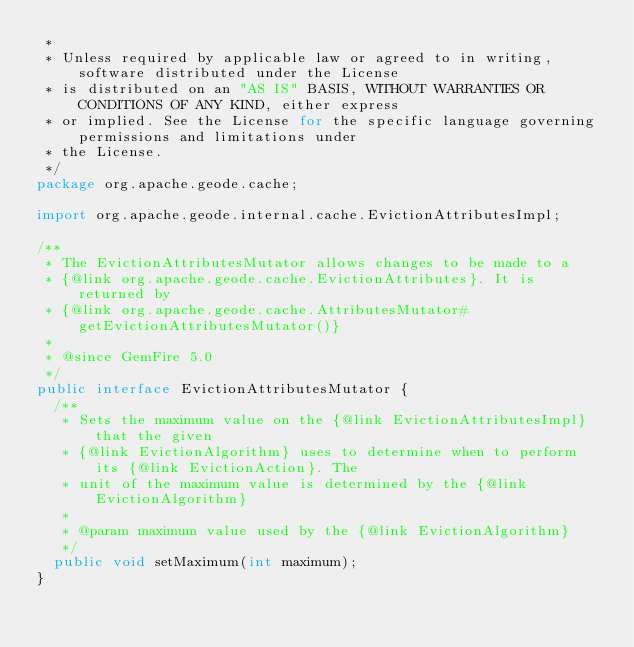<code> <loc_0><loc_0><loc_500><loc_500><_Java_> *
 * Unless required by applicable law or agreed to in writing, software distributed under the License
 * is distributed on an "AS IS" BASIS, WITHOUT WARRANTIES OR CONDITIONS OF ANY KIND, either express
 * or implied. See the License for the specific language governing permissions and limitations under
 * the License.
 */
package org.apache.geode.cache;

import org.apache.geode.internal.cache.EvictionAttributesImpl;

/**
 * The EvictionAttributesMutator allows changes to be made to a
 * {@link org.apache.geode.cache.EvictionAttributes}. It is returned by
 * {@link org.apache.geode.cache.AttributesMutator#getEvictionAttributesMutator()}
 * 
 * @since GemFire 5.0
 */
public interface EvictionAttributesMutator {
  /**
   * Sets the maximum value on the {@link EvictionAttributesImpl} that the given
   * {@link EvictionAlgorithm} uses to determine when to perform its {@link EvictionAction}. The
   * unit of the maximum value is determined by the {@link EvictionAlgorithm}
   * 
   * @param maximum value used by the {@link EvictionAlgorithm}
   */
  public void setMaximum(int maximum);
}
</code> 